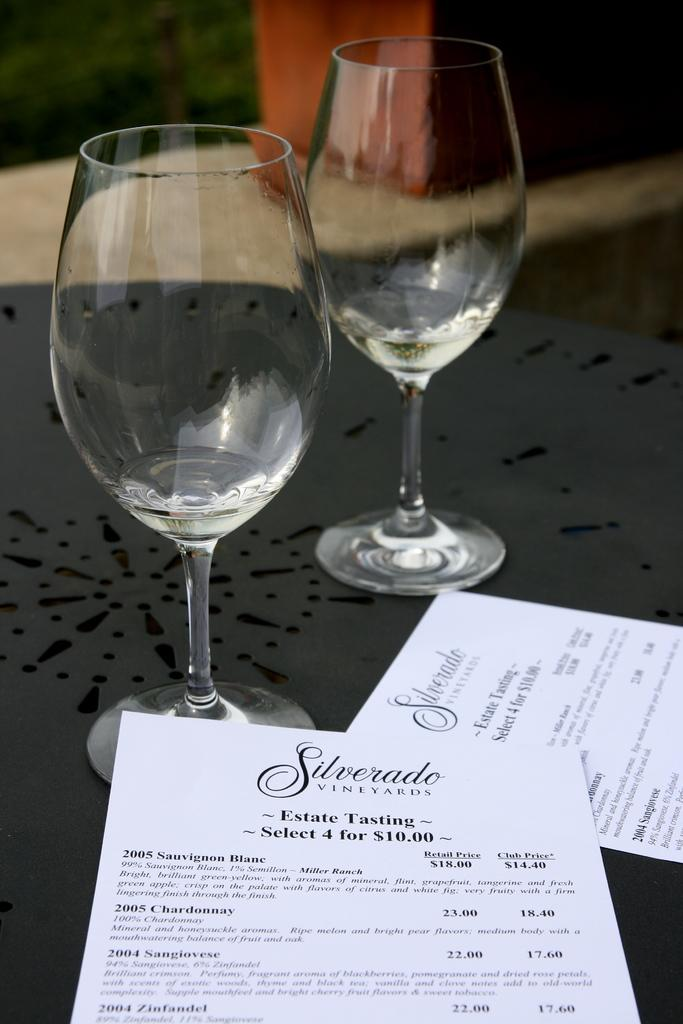What piece of furniture is present in the image? There is a table in the image. What items can be seen on the table? There are two glasses and papers on the table. Is there any color associated with an object on the table? Yes, there is a red color object on the table. What is the name of the beggar standing near the table in the image? There is no beggar present in the image; it only features a table with glasses, papers, and a red color object. What type of stage is visible in the image? There is no stage present in the image; it only features a table with glasses, papers, and a red color object. 